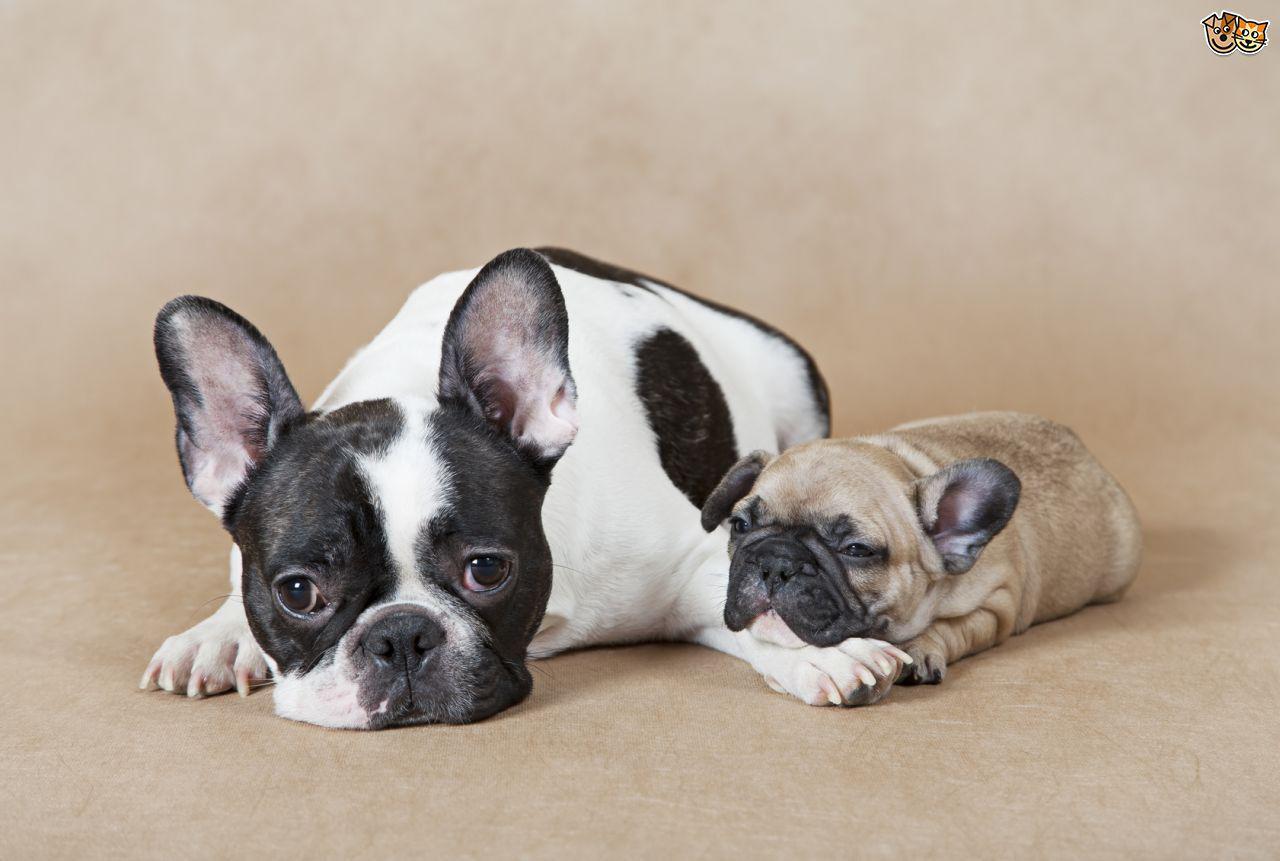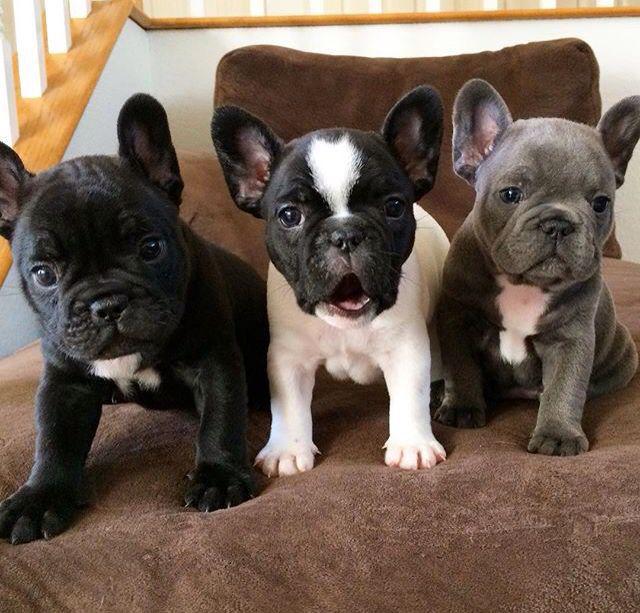The first image is the image on the left, the second image is the image on the right. Analyze the images presented: Is the assertion "A single black dog is opposite at least three dogs of multiple colors." valid? Answer yes or no. No. 